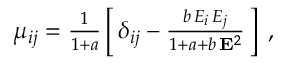Convert formula to latex. <formula><loc_0><loc_0><loc_500><loc_500>\begin{array} { r } { \mu _ { i j } = \frac { 1 } { 1 + a } \left [ \, \delta _ { i j } - \frac { b \, E _ { i } \, E _ { j } } { 1 + a + b \, { E } ^ { 2 } } \, \right ] \, , } \end{array}</formula> 